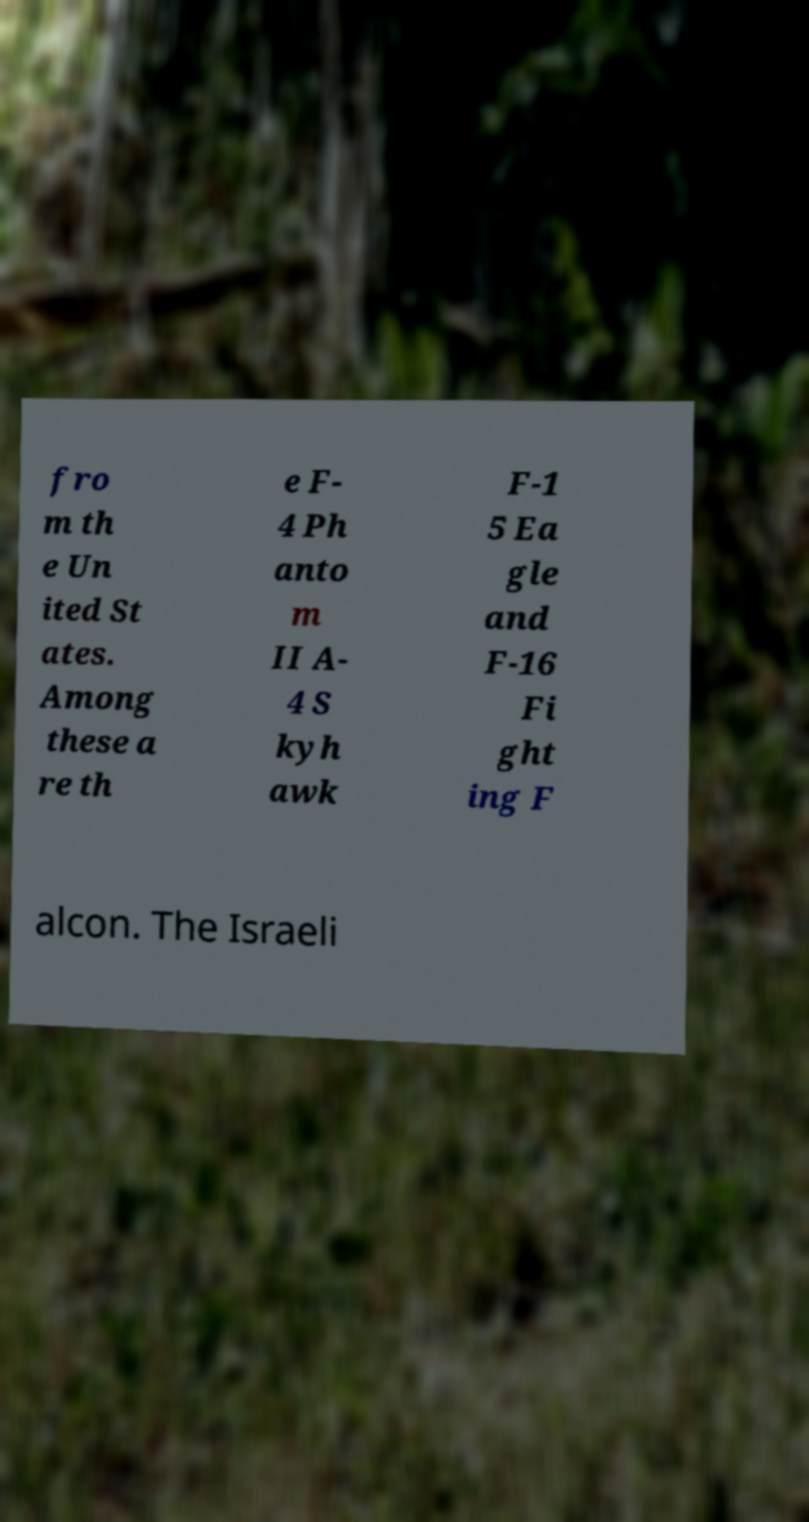Please identify and transcribe the text found in this image. fro m th e Un ited St ates. Among these a re th e F- 4 Ph anto m II A- 4 S kyh awk F-1 5 Ea gle and F-16 Fi ght ing F alcon. The Israeli 